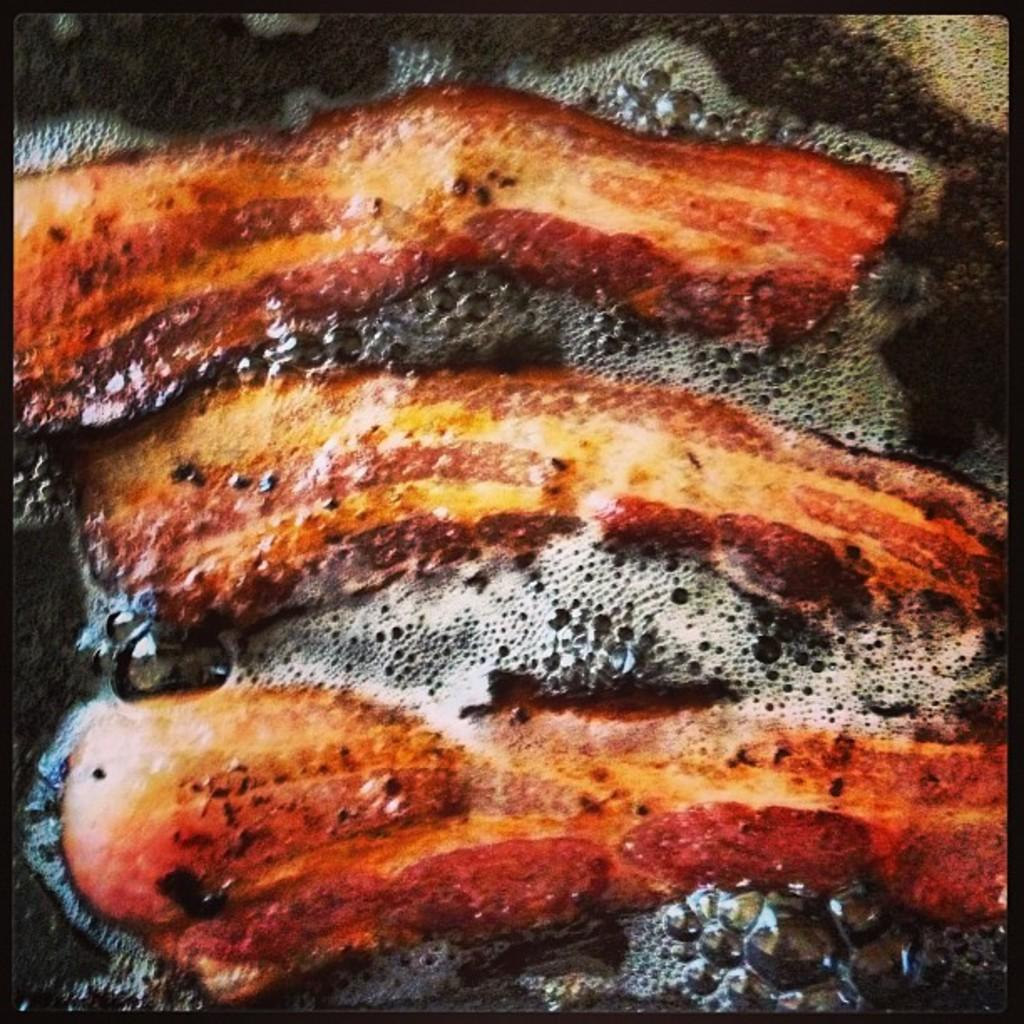What is happening to the food item in the image? The food item is being fried in oil in the image. Can you describe any additional features of the image? The image has a black border. Where is the stove located in the image? There is no stove present in the image. What type of island can be seen in the image? There is no island present in the image. 